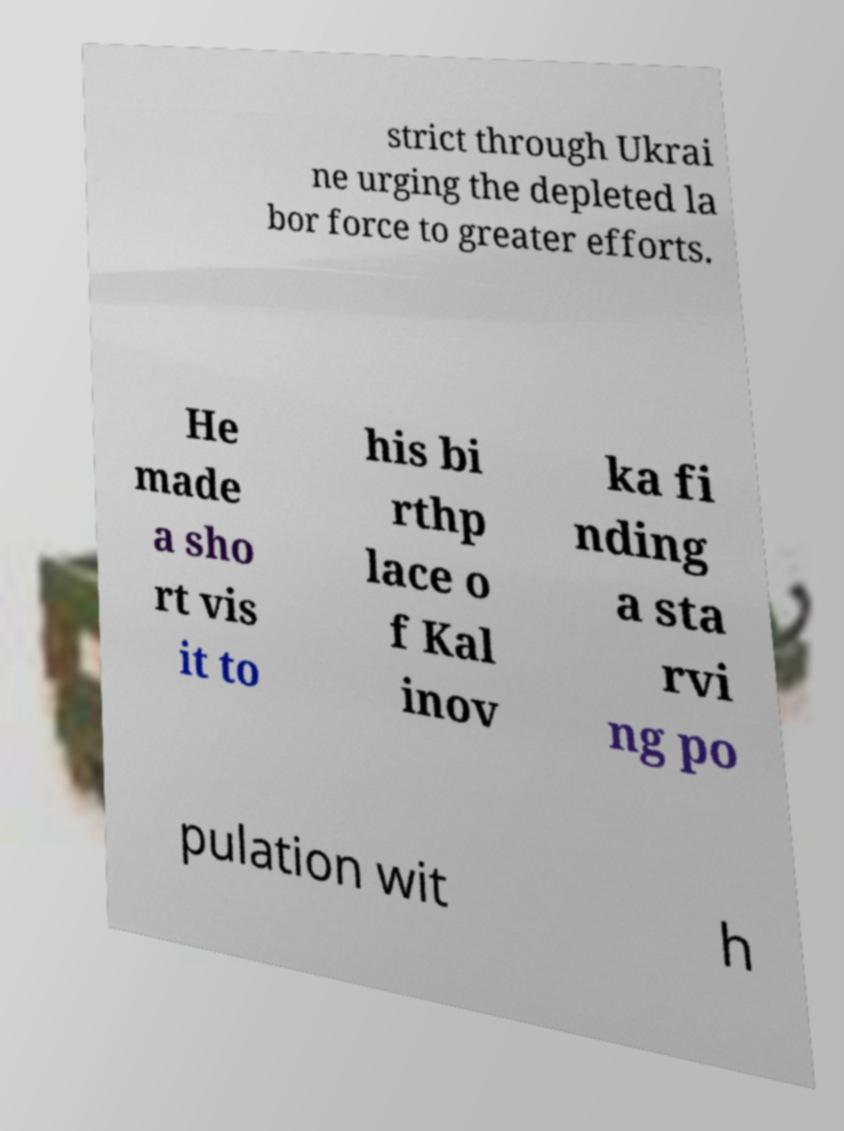Can you accurately transcribe the text from the provided image for me? strict through Ukrai ne urging the depleted la bor force to greater efforts. He made a sho rt vis it to his bi rthp lace o f Kal inov ka fi nding a sta rvi ng po pulation wit h 